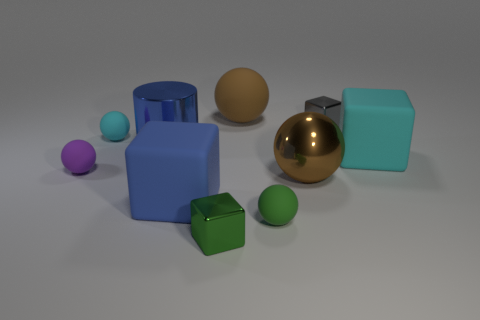The other big matte object that is the same shape as the big cyan rubber object is what color? blue 